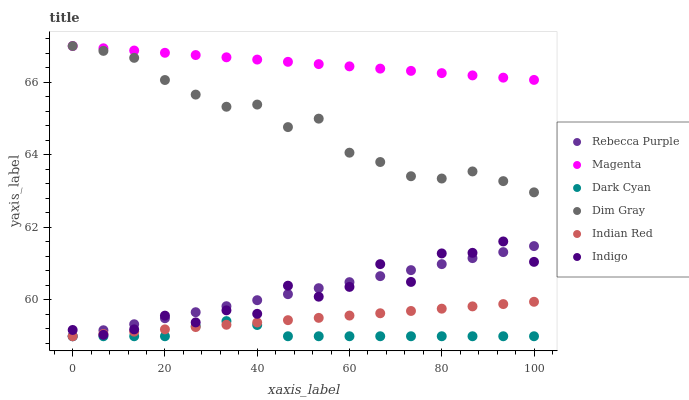Does Dark Cyan have the minimum area under the curve?
Answer yes or no. Yes. Does Magenta have the maximum area under the curve?
Answer yes or no. Yes. Does Indigo have the minimum area under the curve?
Answer yes or no. No. Does Indigo have the maximum area under the curve?
Answer yes or no. No. Is Rebecca Purple the smoothest?
Answer yes or no. Yes. Is Indigo the roughest?
Answer yes or no. Yes. Is Indigo the smoothest?
Answer yes or no. No. Is Rebecca Purple the roughest?
Answer yes or no. No. Does Rebecca Purple have the lowest value?
Answer yes or no. Yes. Does Indigo have the lowest value?
Answer yes or no. No. Does Magenta have the highest value?
Answer yes or no. Yes. Does Indigo have the highest value?
Answer yes or no. No. Is Indigo less than Dim Gray?
Answer yes or no. Yes. Is Magenta greater than Indian Red?
Answer yes or no. Yes. Does Dim Gray intersect Magenta?
Answer yes or no. Yes. Is Dim Gray less than Magenta?
Answer yes or no. No. Is Dim Gray greater than Magenta?
Answer yes or no. No. Does Indigo intersect Dim Gray?
Answer yes or no. No. 